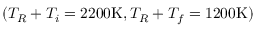Convert formula to latex. <formula><loc_0><loc_0><loc_500><loc_500>( T _ { R } + T _ { i } = 2 2 0 0 K , T _ { R } + T _ { f } = 1 2 0 0 K )</formula> 